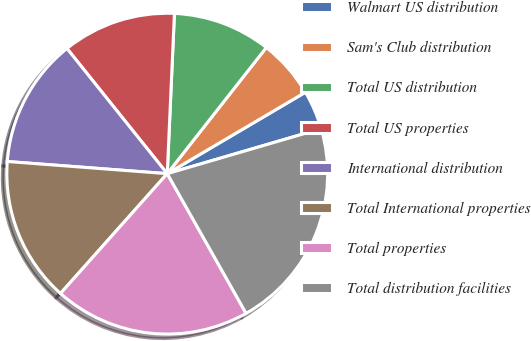Convert chart. <chart><loc_0><loc_0><loc_500><loc_500><pie_chart><fcel>Walmart US distribution<fcel>Sam's Club distribution<fcel>Total US distribution<fcel>Total US properties<fcel>International distribution<fcel>Total International properties<fcel>Total properties<fcel>Total distribution facilities<nl><fcel>3.95%<fcel>5.93%<fcel>9.88%<fcel>11.46%<fcel>13.04%<fcel>14.62%<fcel>19.76%<fcel>21.34%<nl></chart> 